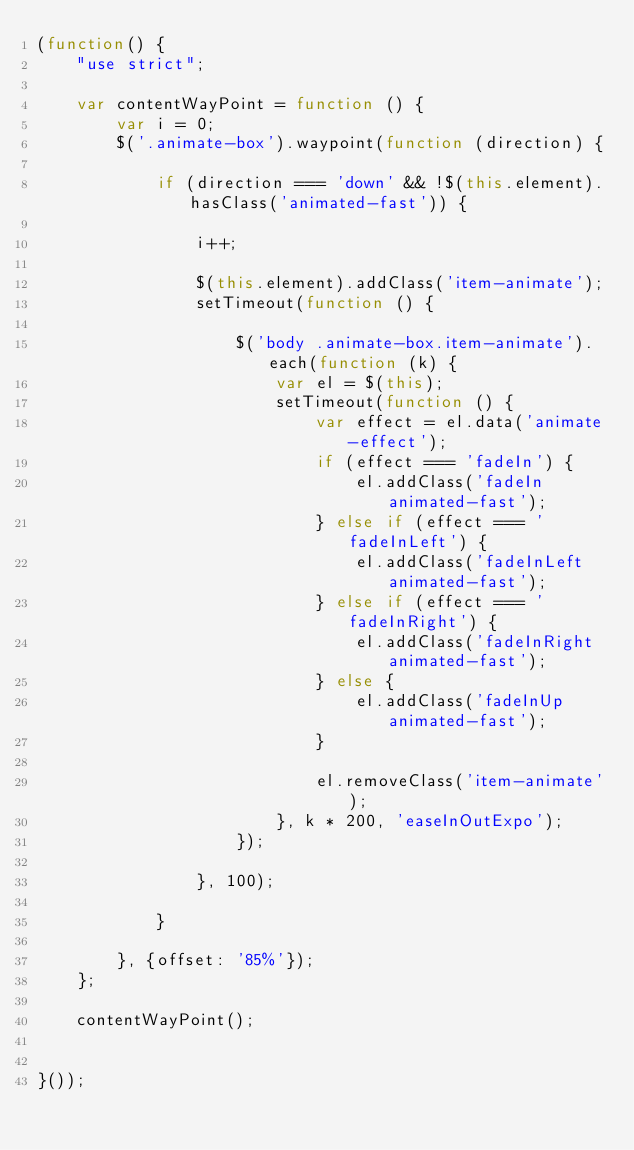<code> <loc_0><loc_0><loc_500><loc_500><_JavaScript_>(function() {
    "use strict";

    var contentWayPoint = function () {
        var i = 0;
        $('.animate-box').waypoint(function (direction) {

            if (direction === 'down' && !$(this.element).hasClass('animated-fast')) {

                i++;

                $(this.element).addClass('item-animate');
                setTimeout(function () {

                    $('body .animate-box.item-animate').each(function (k) {
                        var el = $(this);
                        setTimeout(function () {
                            var effect = el.data('animate-effect');
                            if (effect === 'fadeIn') {
                                el.addClass('fadeIn animated-fast');
                            } else if (effect === 'fadeInLeft') {
                                el.addClass('fadeInLeft animated-fast');
                            } else if (effect === 'fadeInRight') {
                                el.addClass('fadeInRight animated-fast');
                            } else {
                                el.addClass('fadeInUp animated-fast');
                            }

                            el.removeClass('item-animate');
                        }, k * 200, 'easeInOutExpo');
                    });

                }, 100);

            }

        }, {offset: '85%'});
    };

    contentWayPoint();


}());</code> 